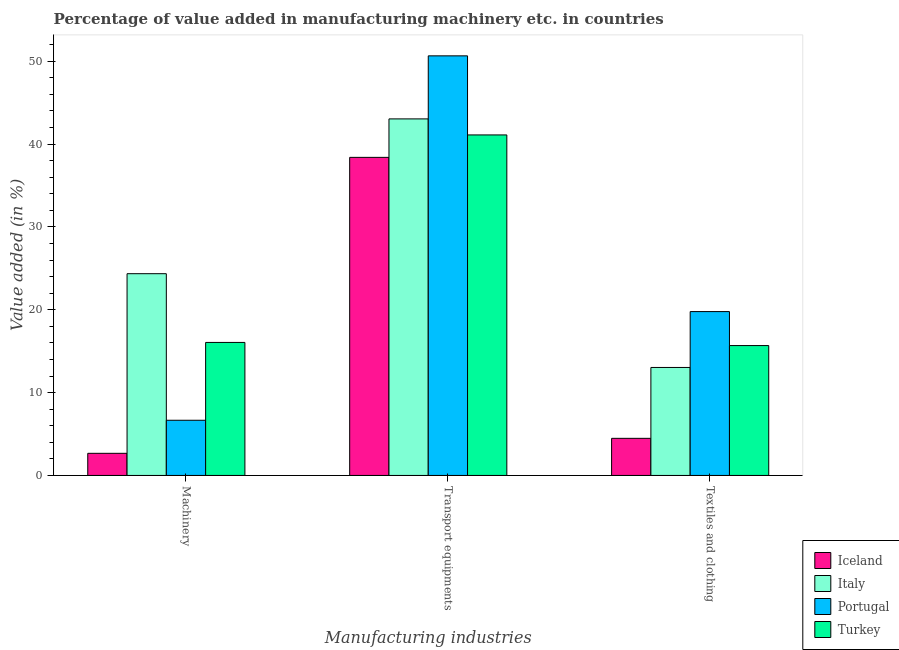How many different coloured bars are there?
Give a very brief answer. 4. Are the number of bars per tick equal to the number of legend labels?
Make the answer very short. Yes. What is the label of the 1st group of bars from the left?
Offer a terse response. Machinery. What is the value added in manufacturing transport equipments in Iceland?
Provide a short and direct response. 38.4. Across all countries, what is the maximum value added in manufacturing transport equipments?
Ensure brevity in your answer.  50.66. Across all countries, what is the minimum value added in manufacturing transport equipments?
Ensure brevity in your answer.  38.4. In which country was the value added in manufacturing transport equipments maximum?
Your answer should be compact. Portugal. What is the total value added in manufacturing textile and clothing in the graph?
Give a very brief answer. 52.98. What is the difference between the value added in manufacturing transport equipments in Italy and that in Turkey?
Offer a very short reply. 1.94. What is the difference between the value added in manufacturing textile and clothing in Iceland and the value added in manufacturing transport equipments in Italy?
Offer a very short reply. -38.56. What is the average value added in manufacturing transport equipments per country?
Offer a terse response. 43.3. What is the difference between the value added in manufacturing transport equipments and value added in manufacturing textile and clothing in Italy?
Make the answer very short. 30.01. What is the ratio of the value added in manufacturing machinery in Italy to that in Turkey?
Your answer should be very brief. 1.52. Is the difference between the value added in manufacturing machinery in Portugal and Turkey greater than the difference between the value added in manufacturing textile and clothing in Portugal and Turkey?
Ensure brevity in your answer.  No. What is the difference between the highest and the second highest value added in manufacturing transport equipments?
Make the answer very short. 7.61. What is the difference between the highest and the lowest value added in manufacturing transport equipments?
Provide a succinct answer. 12.26. Is the sum of the value added in manufacturing machinery in Italy and Portugal greater than the maximum value added in manufacturing transport equipments across all countries?
Offer a very short reply. No. What does the 4th bar from the left in Transport equipments represents?
Offer a very short reply. Turkey. What does the 4th bar from the right in Transport equipments represents?
Ensure brevity in your answer.  Iceland. Is it the case that in every country, the sum of the value added in manufacturing machinery and value added in manufacturing transport equipments is greater than the value added in manufacturing textile and clothing?
Provide a short and direct response. Yes. What is the difference between two consecutive major ticks on the Y-axis?
Give a very brief answer. 10. Are the values on the major ticks of Y-axis written in scientific E-notation?
Offer a terse response. No. Does the graph contain any zero values?
Offer a very short reply. No. How many legend labels are there?
Make the answer very short. 4. What is the title of the graph?
Make the answer very short. Percentage of value added in manufacturing machinery etc. in countries. What is the label or title of the X-axis?
Offer a very short reply. Manufacturing industries. What is the label or title of the Y-axis?
Make the answer very short. Value added (in %). What is the Value added (in %) of Iceland in Machinery?
Your answer should be very brief. 2.67. What is the Value added (in %) of Italy in Machinery?
Offer a terse response. 24.36. What is the Value added (in %) of Portugal in Machinery?
Keep it short and to the point. 6.66. What is the Value added (in %) of Turkey in Machinery?
Keep it short and to the point. 16.06. What is the Value added (in %) of Iceland in Transport equipments?
Ensure brevity in your answer.  38.4. What is the Value added (in %) in Italy in Transport equipments?
Make the answer very short. 43.05. What is the Value added (in %) in Portugal in Transport equipments?
Your answer should be compact. 50.66. What is the Value added (in %) of Turkey in Transport equipments?
Offer a very short reply. 41.11. What is the Value added (in %) in Iceland in Textiles and clothing?
Offer a very short reply. 4.48. What is the Value added (in %) in Italy in Textiles and clothing?
Your answer should be compact. 13.04. What is the Value added (in %) of Portugal in Textiles and clothing?
Offer a terse response. 19.78. What is the Value added (in %) in Turkey in Textiles and clothing?
Provide a succinct answer. 15.68. Across all Manufacturing industries, what is the maximum Value added (in %) of Iceland?
Your answer should be compact. 38.4. Across all Manufacturing industries, what is the maximum Value added (in %) in Italy?
Offer a very short reply. 43.05. Across all Manufacturing industries, what is the maximum Value added (in %) of Portugal?
Keep it short and to the point. 50.66. Across all Manufacturing industries, what is the maximum Value added (in %) of Turkey?
Your answer should be very brief. 41.11. Across all Manufacturing industries, what is the minimum Value added (in %) in Iceland?
Your response must be concise. 2.67. Across all Manufacturing industries, what is the minimum Value added (in %) of Italy?
Ensure brevity in your answer.  13.04. Across all Manufacturing industries, what is the minimum Value added (in %) of Portugal?
Your response must be concise. 6.66. Across all Manufacturing industries, what is the minimum Value added (in %) in Turkey?
Keep it short and to the point. 15.68. What is the total Value added (in %) in Iceland in the graph?
Give a very brief answer. 45.55. What is the total Value added (in %) in Italy in the graph?
Offer a terse response. 80.44. What is the total Value added (in %) of Portugal in the graph?
Provide a short and direct response. 77.1. What is the total Value added (in %) in Turkey in the graph?
Make the answer very short. 72.85. What is the difference between the Value added (in %) in Iceland in Machinery and that in Transport equipments?
Your response must be concise. -35.73. What is the difference between the Value added (in %) of Italy in Machinery and that in Transport equipments?
Your response must be concise. -18.69. What is the difference between the Value added (in %) in Portugal in Machinery and that in Transport equipments?
Your answer should be compact. -43.99. What is the difference between the Value added (in %) in Turkey in Machinery and that in Transport equipments?
Provide a short and direct response. -25.05. What is the difference between the Value added (in %) of Iceland in Machinery and that in Textiles and clothing?
Give a very brief answer. -1.81. What is the difference between the Value added (in %) in Italy in Machinery and that in Textiles and clothing?
Your answer should be very brief. 11.32. What is the difference between the Value added (in %) of Portugal in Machinery and that in Textiles and clothing?
Provide a succinct answer. -13.12. What is the difference between the Value added (in %) of Turkey in Machinery and that in Textiles and clothing?
Provide a succinct answer. 0.38. What is the difference between the Value added (in %) in Iceland in Transport equipments and that in Textiles and clothing?
Offer a terse response. 33.92. What is the difference between the Value added (in %) of Italy in Transport equipments and that in Textiles and clothing?
Offer a terse response. 30.01. What is the difference between the Value added (in %) of Portugal in Transport equipments and that in Textiles and clothing?
Provide a short and direct response. 30.87. What is the difference between the Value added (in %) in Turkey in Transport equipments and that in Textiles and clothing?
Provide a succinct answer. 25.43. What is the difference between the Value added (in %) of Iceland in Machinery and the Value added (in %) of Italy in Transport equipments?
Provide a succinct answer. -40.37. What is the difference between the Value added (in %) of Iceland in Machinery and the Value added (in %) of Portugal in Transport equipments?
Your response must be concise. -47.99. What is the difference between the Value added (in %) in Iceland in Machinery and the Value added (in %) in Turkey in Transport equipments?
Offer a terse response. -38.44. What is the difference between the Value added (in %) in Italy in Machinery and the Value added (in %) in Portugal in Transport equipments?
Ensure brevity in your answer.  -26.3. What is the difference between the Value added (in %) in Italy in Machinery and the Value added (in %) in Turkey in Transport equipments?
Ensure brevity in your answer.  -16.75. What is the difference between the Value added (in %) of Portugal in Machinery and the Value added (in %) of Turkey in Transport equipments?
Ensure brevity in your answer.  -34.45. What is the difference between the Value added (in %) in Iceland in Machinery and the Value added (in %) in Italy in Textiles and clothing?
Keep it short and to the point. -10.37. What is the difference between the Value added (in %) of Iceland in Machinery and the Value added (in %) of Portugal in Textiles and clothing?
Your response must be concise. -17.11. What is the difference between the Value added (in %) in Iceland in Machinery and the Value added (in %) in Turkey in Textiles and clothing?
Ensure brevity in your answer.  -13.01. What is the difference between the Value added (in %) of Italy in Machinery and the Value added (in %) of Portugal in Textiles and clothing?
Ensure brevity in your answer.  4.57. What is the difference between the Value added (in %) in Italy in Machinery and the Value added (in %) in Turkey in Textiles and clothing?
Your answer should be compact. 8.68. What is the difference between the Value added (in %) in Portugal in Machinery and the Value added (in %) in Turkey in Textiles and clothing?
Provide a succinct answer. -9.02. What is the difference between the Value added (in %) in Iceland in Transport equipments and the Value added (in %) in Italy in Textiles and clothing?
Your answer should be very brief. 25.36. What is the difference between the Value added (in %) in Iceland in Transport equipments and the Value added (in %) in Portugal in Textiles and clothing?
Your response must be concise. 18.62. What is the difference between the Value added (in %) of Iceland in Transport equipments and the Value added (in %) of Turkey in Textiles and clothing?
Your response must be concise. 22.72. What is the difference between the Value added (in %) in Italy in Transport equipments and the Value added (in %) in Portugal in Textiles and clothing?
Provide a succinct answer. 23.26. What is the difference between the Value added (in %) of Italy in Transport equipments and the Value added (in %) of Turkey in Textiles and clothing?
Your response must be concise. 27.37. What is the difference between the Value added (in %) in Portugal in Transport equipments and the Value added (in %) in Turkey in Textiles and clothing?
Provide a short and direct response. 34.98. What is the average Value added (in %) of Iceland per Manufacturing industries?
Provide a short and direct response. 15.18. What is the average Value added (in %) of Italy per Manufacturing industries?
Your answer should be very brief. 26.81. What is the average Value added (in %) of Portugal per Manufacturing industries?
Ensure brevity in your answer.  25.7. What is the average Value added (in %) in Turkey per Manufacturing industries?
Offer a terse response. 24.28. What is the difference between the Value added (in %) of Iceland and Value added (in %) of Italy in Machinery?
Provide a short and direct response. -21.69. What is the difference between the Value added (in %) in Iceland and Value added (in %) in Portugal in Machinery?
Offer a terse response. -3.99. What is the difference between the Value added (in %) of Iceland and Value added (in %) of Turkey in Machinery?
Offer a very short reply. -13.39. What is the difference between the Value added (in %) of Italy and Value added (in %) of Portugal in Machinery?
Provide a succinct answer. 17.7. What is the difference between the Value added (in %) of Italy and Value added (in %) of Turkey in Machinery?
Give a very brief answer. 8.3. What is the difference between the Value added (in %) in Portugal and Value added (in %) in Turkey in Machinery?
Provide a short and direct response. -9.4. What is the difference between the Value added (in %) of Iceland and Value added (in %) of Italy in Transport equipments?
Your answer should be compact. -4.65. What is the difference between the Value added (in %) of Iceland and Value added (in %) of Portugal in Transport equipments?
Keep it short and to the point. -12.26. What is the difference between the Value added (in %) in Iceland and Value added (in %) in Turkey in Transport equipments?
Make the answer very short. -2.71. What is the difference between the Value added (in %) in Italy and Value added (in %) in Portugal in Transport equipments?
Ensure brevity in your answer.  -7.61. What is the difference between the Value added (in %) in Italy and Value added (in %) in Turkey in Transport equipments?
Offer a very short reply. 1.94. What is the difference between the Value added (in %) in Portugal and Value added (in %) in Turkey in Transport equipments?
Your answer should be compact. 9.55. What is the difference between the Value added (in %) of Iceland and Value added (in %) of Italy in Textiles and clothing?
Your response must be concise. -8.56. What is the difference between the Value added (in %) of Iceland and Value added (in %) of Portugal in Textiles and clothing?
Provide a short and direct response. -15.3. What is the difference between the Value added (in %) in Iceland and Value added (in %) in Turkey in Textiles and clothing?
Keep it short and to the point. -11.2. What is the difference between the Value added (in %) of Italy and Value added (in %) of Portugal in Textiles and clothing?
Ensure brevity in your answer.  -6.75. What is the difference between the Value added (in %) in Italy and Value added (in %) in Turkey in Textiles and clothing?
Ensure brevity in your answer.  -2.64. What is the difference between the Value added (in %) of Portugal and Value added (in %) of Turkey in Textiles and clothing?
Provide a short and direct response. 4.1. What is the ratio of the Value added (in %) of Iceland in Machinery to that in Transport equipments?
Provide a succinct answer. 0.07. What is the ratio of the Value added (in %) of Italy in Machinery to that in Transport equipments?
Your answer should be very brief. 0.57. What is the ratio of the Value added (in %) of Portugal in Machinery to that in Transport equipments?
Give a very brief answer. 0.13. What is the ratio of the Value added (in %) in Turkey in Machinery to that in Transport equipments?
Your response must be concise. 0.39. What is the ratio of the Value added (in %) in Iceland in Machinery to that in Textiles and clothing?
Provide a short and direct response. 0.6. What is the ratio of the Value added (in %) in Italy in Machinery to that in Textiles and clothing?
Give a very brief answer. 1.87. What is the ratio of the Value added (in %) of Portugal in Machinery to that in Textiles and clothing?
Offer a terse response. 0.34. What is the ratio of the Value added (in %) in Turkey in Machinery to that in Textiles and clothing?
Ensure brevity in your answer.  1.02. What is the ratio of the Value added (in %) of Iceland in Transport equipments to that in Textiles and clothing?
Give a very brief answer. 8.57. What is the ratio of the Value added (in %) in Italy in Transport equipments to that in Textiles and clothing?
Make the answer very short. 3.3. What is the ratio of the Value added (in %) of Portugal in Transport equipments to that in Textiles and clothing?
Ensure brevity in your answer.  2.56. What is the ratio of the Value added (in %) in Turkey in Transport equipments to that in Textiles and clothing?
Keep it short and to the point. 2.62. What is the difference between the highest and the second highest Value added (in %) in Iceland?
Your answer should be very brief. 33.92. What is the difference between the highest and the second highest Value added (in %) of Italy?
Make the answer very short. 18.69. What is the difference between the highest and the second highest Value added (in %) in Portugal?
Provide a succinct answer. 30.87. What is the difference between the highest and the second highest Value added (in %) in Turkey?
Provide a short and direct response. 25.05. What is the difference between the highest and the lowest Value added (in %) in Iceland?
Provide a succinct answer. 35.73. What is the difference between the highest and the lowest Value added (in %) of Italy?
Keep it short and to the point. 30.01. What is the difference between the highest and the lowest Value added (in %) of Portugal?
Provide a succinct answer. 43.99. What is the difference between the highest and the lowest Value added (in %) of Turkey?
Give a very brief answer. 25.43. 